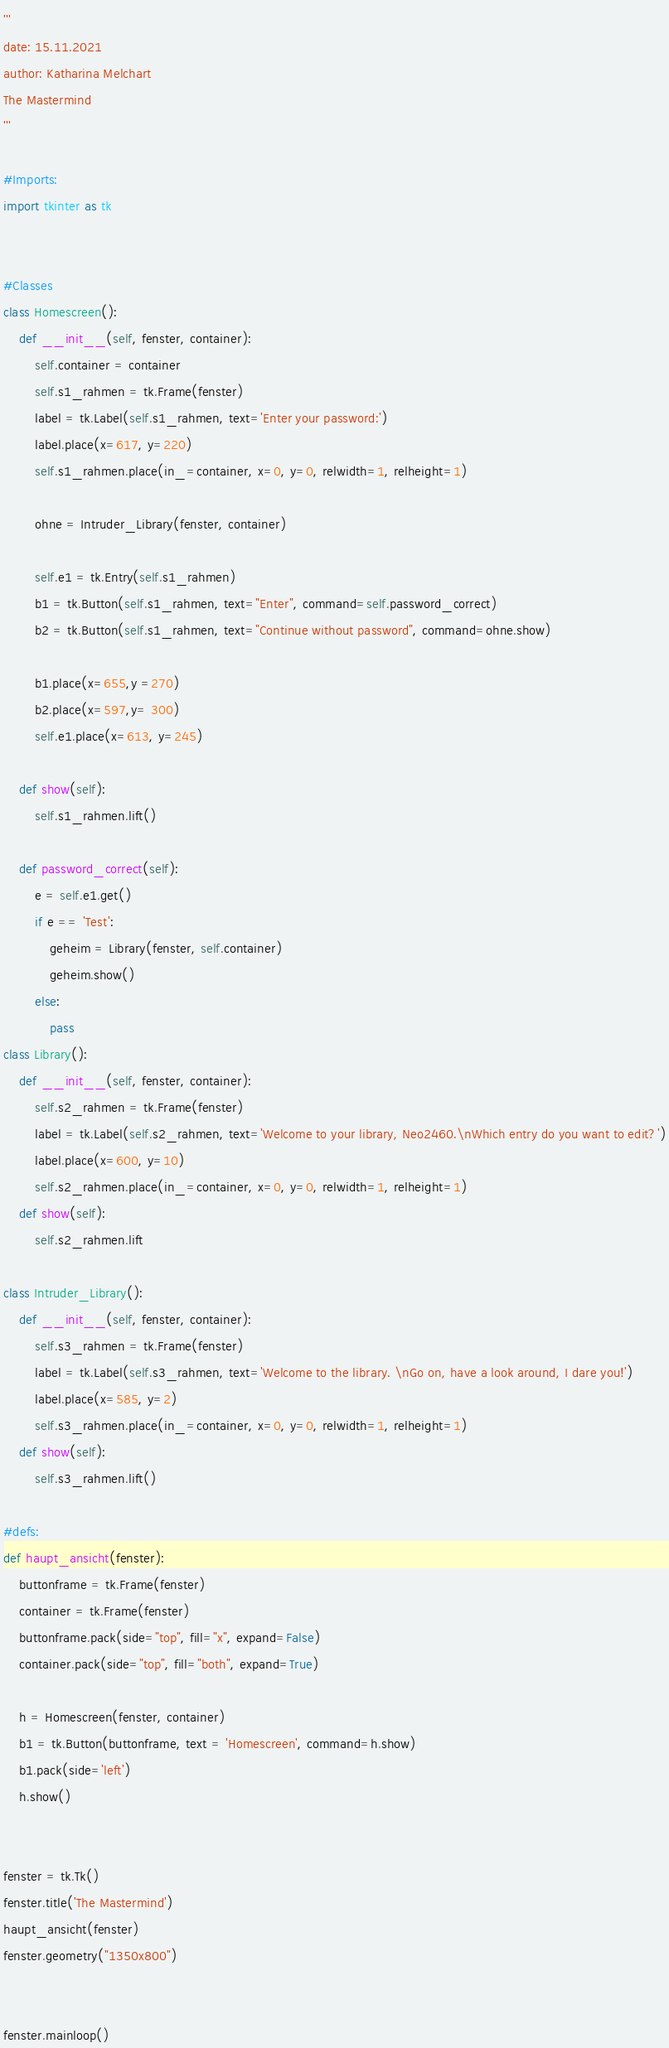<code> <loc_0><loc_0><loc_500><loc_500><_Python_>'''
date: 15.11.2021
author: Katharina Melchart
The Mastermind
'''

#Imports:
import tkinter as tk


#Classes
class Homescreen():
    def __init__(self, fenster, container):
        self.container = container
        self.s1_rahmen = tk.Frame(fenster)
        label = tk.Label(self.s1_rahmen, text='Enter your password:')
        label.place(x=617, y=220)
        self.s1_rahmen.place(in_=container, x=0, y=0, relwidth=1, relheight=1)

        ohne = Intruder_Library(fenster, container)

        self.e1 = tk.Entry(self.s1_rahmen)
        b1 = tk.Button(self.s1_rahmen, text="Enter", command=self.password_correct)
        b2 = tk.Button(self.s1_rahmen, text="Continue without password", command=ohne.show)

        b1.place(x=655,y =270)
        b2.place(x=597,y= 300)
        self.e1.place(x=613, y=245)

    def show(self):
        self.s1_rahmen.lift()

    def password_correct(self):
        e = self.e1.get()
        if e == 'Test':
            geheim = Library(fenster, self.container)
            geheim.show()
        else:
            pass
class Library():
    def __init__(self, fenster, container):
        self.s2_rahmen = tk.Frame(fenster)
        label = tk.Label(self.s2_rahmen, text='Welcome to your library, Neo2460.\nWhich entry do you want to edit?')
        label.place(x=600, y=10)
        self.s2_rahmen.place(in_=container, x=0, y=0, relwidth=1, relheight=1)
    def show(self):
        self.s2_rahmen.lift

class Intruder_Library():
    def __init__(self, fenster, container):
        self.s3_rahmen = tk.Frame(fenster)
        label = tk.Label(self.s3_rahmen, text='Welcome to the library. \nGo on, have a look around, I dare you!')
        label.place(x=585, y=2)
        self.s3_rahmen.place(in_=container, x=0, y=0, relwidth=1, relheight=1)
    def show(self):
        self.s3_rahmen.lift()

#defs:
def haupt_ansicht(fenster):
    buttonframe = tk.Frame(fenster)
    container = tk.Frame(fenster)
    buttonframe.pack(side="top", fill="x", expand=False)
    container.pack(side="top", fill="both", expand=True)

    h = Homescreen(fenster, container)
    b1 = tk.Button(buttonframe, text = 'Homescreen', command=h.show)
    b1.pack(side='left')
    h.show()


fenster = tk.Tk()
fenster.title('The Mastermind')
haupt_ansicht(fenster)
fenster.geometry("1350x800")


fenster.mainloop()
</code> 